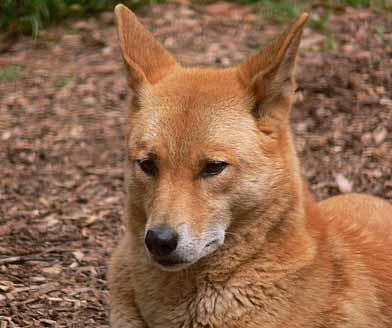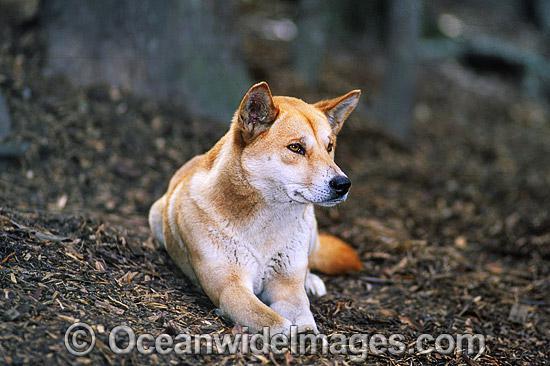The first image is the image on the left, the second image is the image on the right. Assess this claim about the two images: "The same number of canines are shown in the left and right images.". Correct or not? Answer yes or no. Yes. 